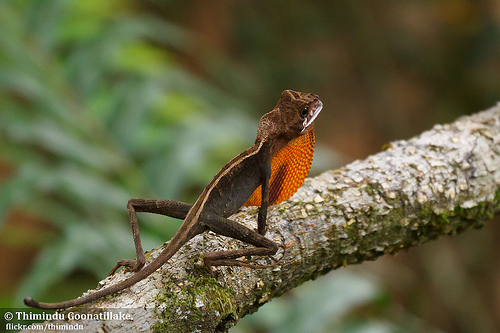<image>
Can you confirm if the lizard is to the left of the branch? No. The lizard is not to the left of the branch. From this viewpoint, they have a different horizontal relationship. Is the branch behind the lizard? No. The branch is not behind the lizard. From this viewpoint, the branch appears to be positioned elsewhere in the scene. 